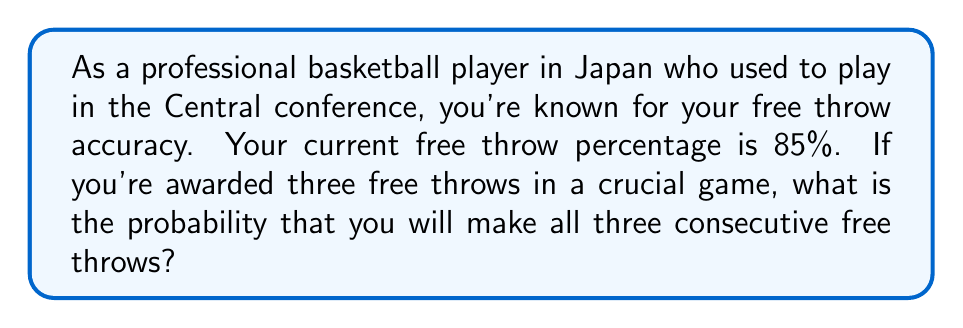Can you solve this math problem? Let's approach this step-by-step:

1) First, we need to understand what the question is asking. We're looking for the probability of making all three free throws in a row.

2) Your free throw percentage is 85%, which means:
   $P(\text{making one free throw}) = 0.85$

3) For independent events (each free throw is independent of the others), we multiply the individual probabilities to find the probability of all events occurring.

4) The probability of making all three free throws is:
   $P(\text{all three}) = P(\text{first}) \times P(\text{second}) \times P(\text{third})$

5) Since each free throw has the same probability:
   $P(\text{all three}) = 0.85 \times 0.85 \times 0.85$

6) We can write this as:
   $P(\text{all three}) = (0.85)^3$

7) Calculating this:
   $P(\text{all three}) = 0.614125$

8) Converting to a percentage:
   $0.614125 \times 100\% = 61.4125\%$

Therefore, the probability of making all three consecutive free throws is approximately 61.41%.
Answer: The probability of making all three consecutive free throws is $0.614125$ or approximately $61.41\%$. 